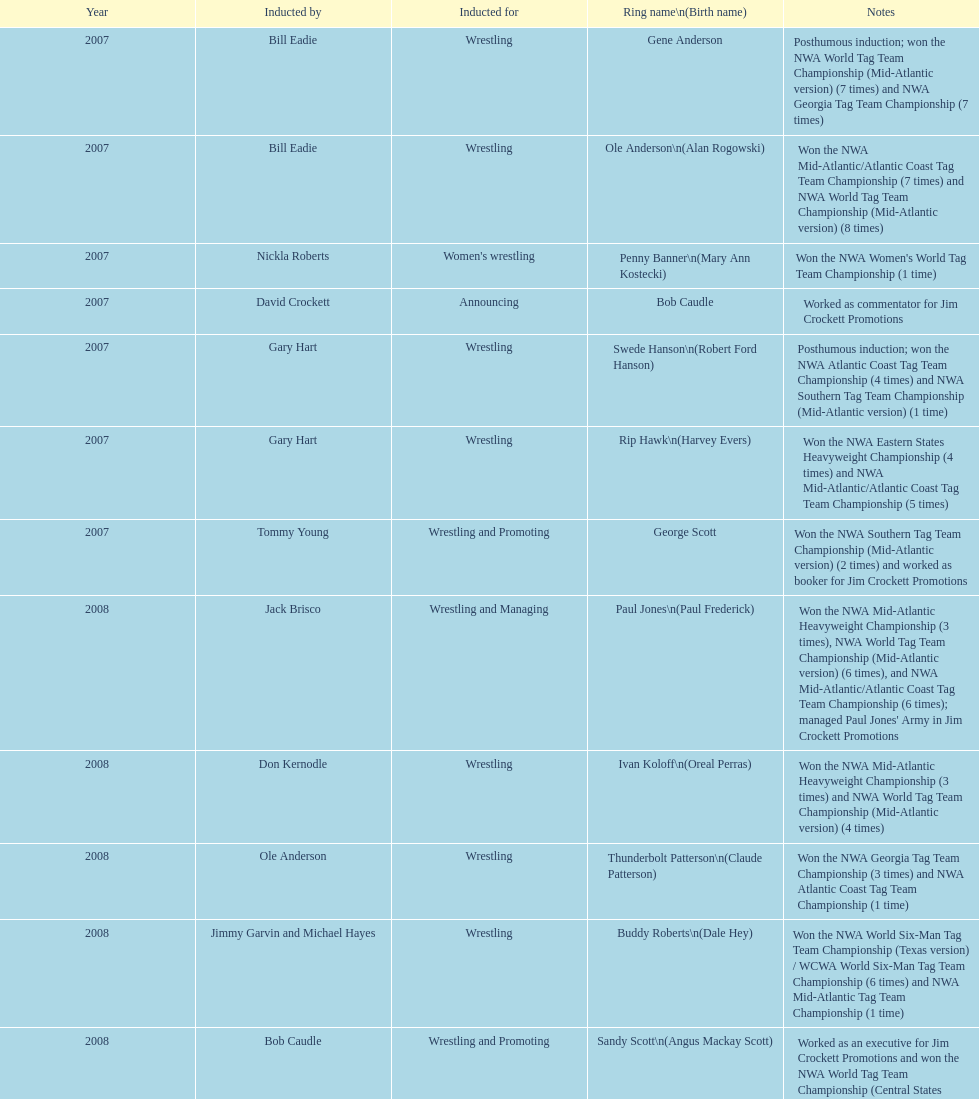Tell me an inductee that was not living at the time. Gene Anderson. 